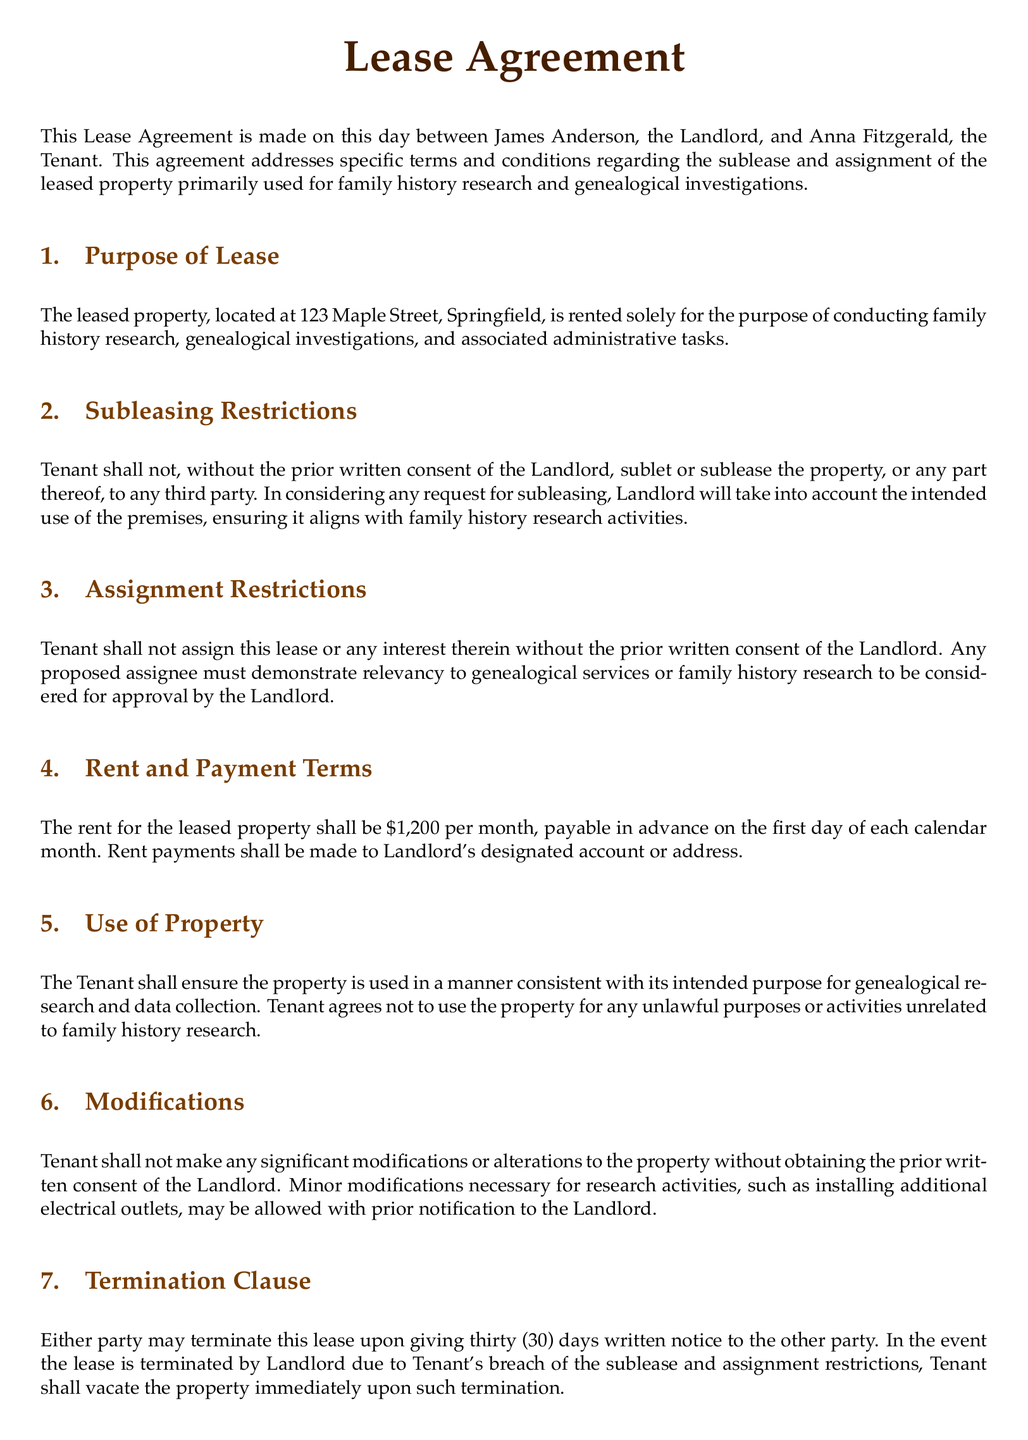What is the address of the leased property? The address is specified in the document as 123 Maple Street, Springfield.
Answer: 123 Maple Street, Springfield Who is the Landlord? The document identifies James Anderson as the Landlord.
Answer: James Anderson What is the monthly rent amount? The document states that the rent for the leased property is $1,200 per month.
Answer: $1,200 What is the notice period for termination of the lease? The document specifies that either party may terminate the lease upon giving thirty (30) days written notice.
Answer: thirty (30) days What activities is the property intended for? The document indicates that the property is rented solely for family history research and genealogical investigations.
Answer: family history research and genealogical investigations What must a proposed assignee demonstrate? The document requires that any proposed assignee must demonstrate relevancy to genealogical services or family history research.
Answer: relevancy to genealogical services or family history research Can the Tenant modify the property? The document states that Tenant shall not make significant modifications without prior written consent from the Landlord.
Answer: No, significant modifications require prior written consent What is the governing law stated in the Lease Agreement? The document specifies that the Lease Agreement shall be governed by the laws of the State of Illinois.
Answer: laws of the State of Illinois What is the effective date of the Lease Agreement? The document notes that the Lease Agreement is made on September 27, 2023.
Answer: September 27, 2023 